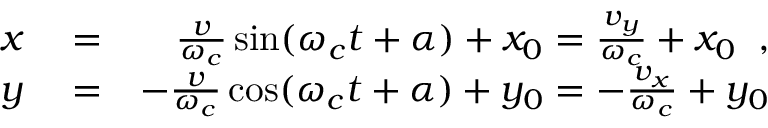<formula> <loc_0><loc_0><loc_500><loc_500>\begin{array} { r l r } { x } & = } & { \frac { v } { \omega _ { c } } \sin ( \omega _ { c } t + \alpha ) + x _ { 0 } = \frac { v _ { y } } { \omega _ { c } } + x _ { 0 } \, , } \\ { y } & = } & { - \frac { v } { \omega _ { c } } \cos ( \omega _ { c } t + \alpha ) + y _ { 0 } = - \frac { v _ { x } } { \omega _ { c } } + y _ { 0 } } \end{array}</formula> 